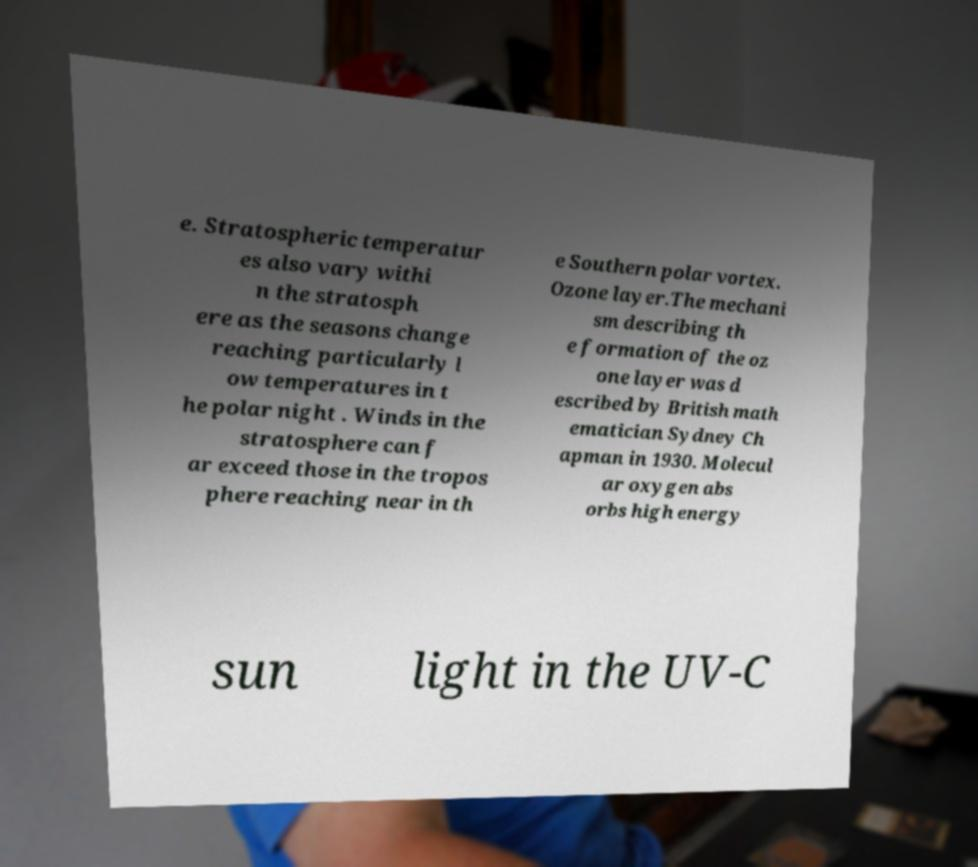Could you assist in decoding the text presented in this image and type it out clearly? e. Stratospheric temperatur es also vary withi n the stratosph ere as the seasons change reaching particularly l ow temperatures in t he polar night . Winds in the stratosphere can f ar exceed those in the tropos phere reaching near in th e Southern polar vortex. Ozone layer.The mechani sm describing th e formation of the oz one layer was d escribed by British math ematician Sydney Ch apman in 1930. Molecul ar oxygen abs orbs high energy sun light in the UV-C 